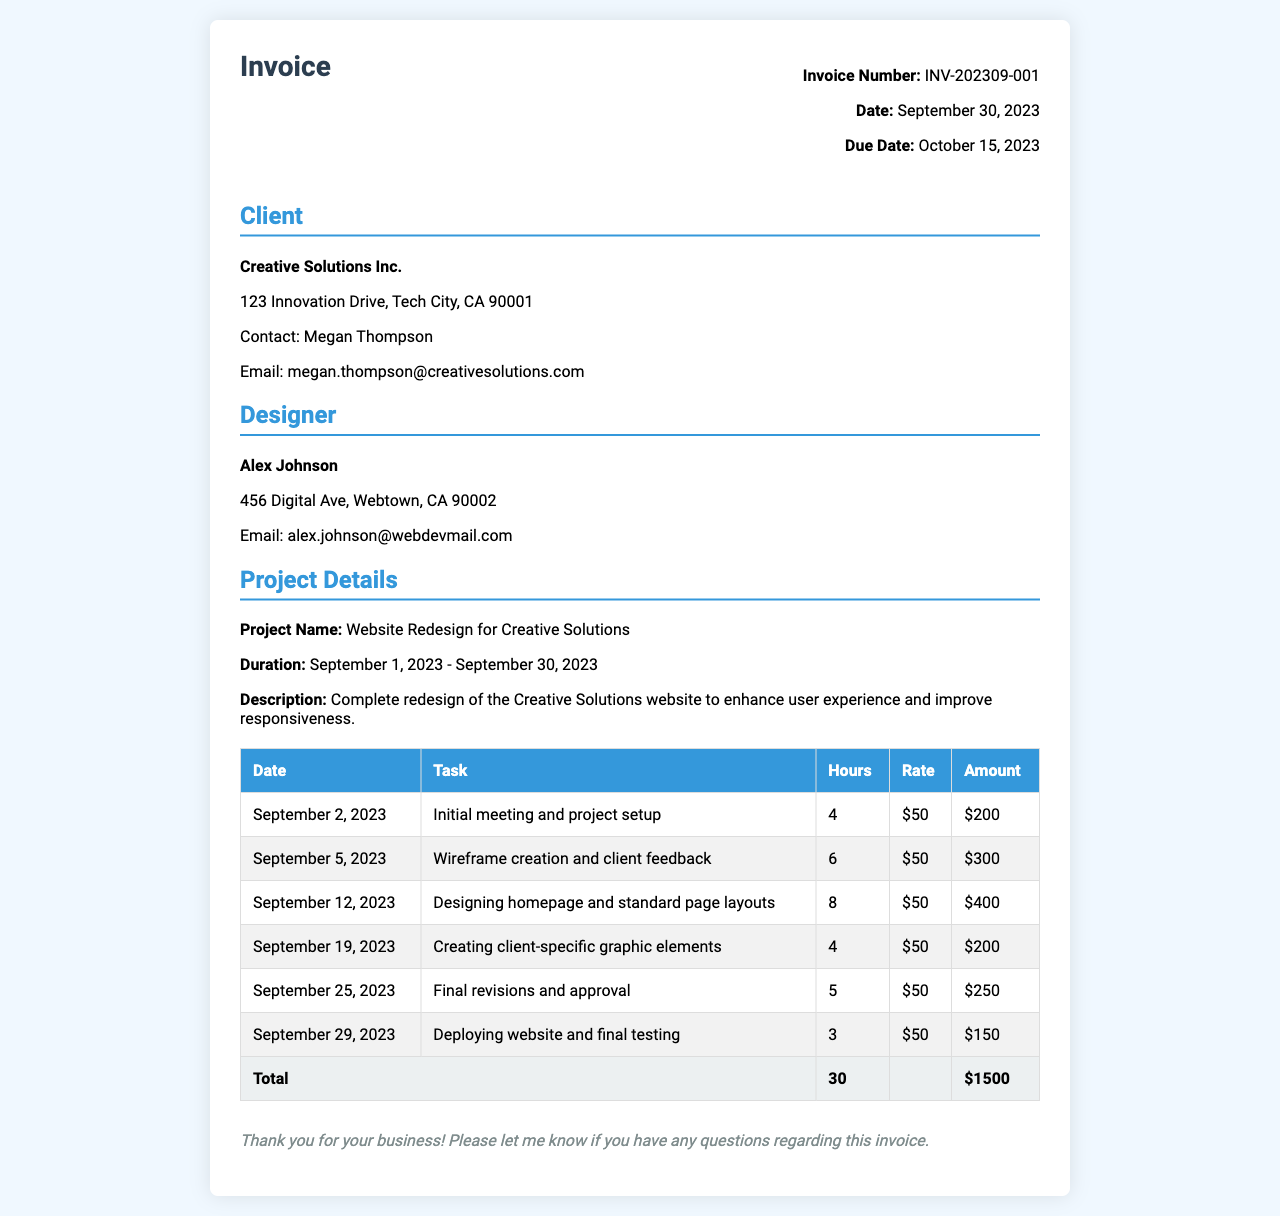What is the invoice number? The invoice number is listed in the document header as a unique identifier for this invoice.
Answer: INV-202309-001 Who is the client? The client's name is provided in the client information section of the invoice.
Answer: Creative Solutions Inc What is the hourly rate? The hourly rate is specified in each task row of the invoice table.
Answer: $50 How many hours were worked in total? The total hours worked are aggregated at the bottom of the invoice in the totals row.
Answer: 30 What was the project name? The project name is stated in the project details section of the invoice.
Answer: Website Redesign for Creative Solutions When was the invoice date? The date of the invoice is noted in the invoice header, indicating when the invoice was generated.
Answer: September 30, 2023 What is the total amount due? The total amount due is calculated and provided in the totals row of the invoice table.
Answer: $1500 What deliverable was completed on September 19, 2023? The task completed on this date is provided in the task column of the invoice table.
Answer: Creating client-specific graphic elements What is the due date for the invoice payment? The due date is indicated in the invoice header, specifying when payment is expected.
Answer: October 15, 2023 Who is the contact person for the client? The contact person is listed in the client information section.
Answer: Megan Thompson 